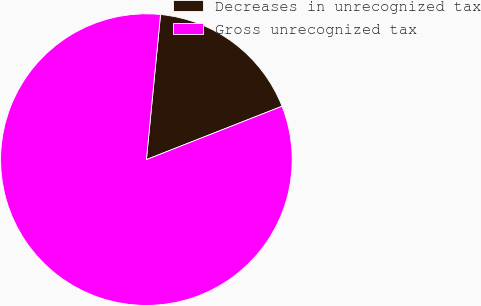<chart> <loc_0><loc_0><loc_500><loc_500><pie_chart><fcel>Decreases in unrecognized tax<fcel>Gross unrecognized tax<nl><fcel>17.49%<fcel>82.51%<nl></chart> 